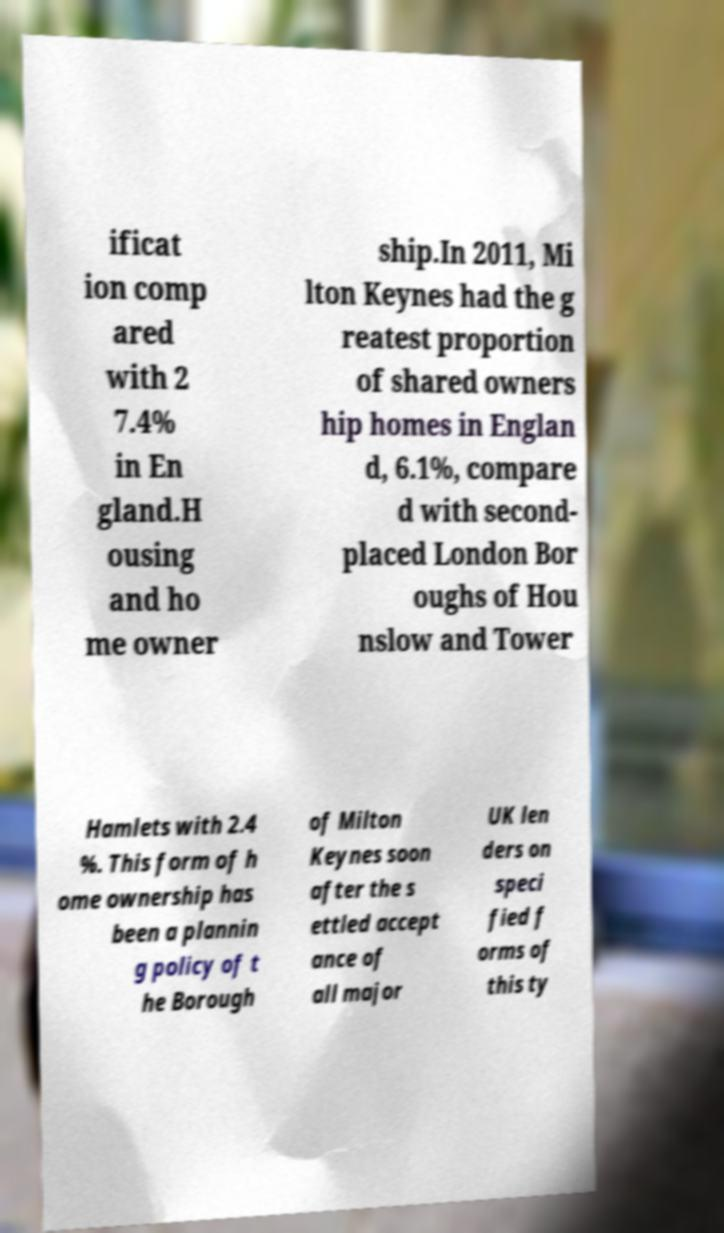There's text embedded in this image that I need extracted. Can you transcribe it verbatim? ificat ion comp ared with 2 7.4% in En gland.H ousing and ho me owner ship.In 2011, Mi lton Keynes had the g reatest proportion of shared owners hip homes in Englan d, 6.1%, compare d with second- placed London Bor oughs of Hou nslow and Tower Hamlets with 2.4 %. This form of h ome ownership has been a plannin g policy of t he Borough of Milton Keynes soon after the s ettled accept ance of all major UK len ders on speci fied f orms of this ty 